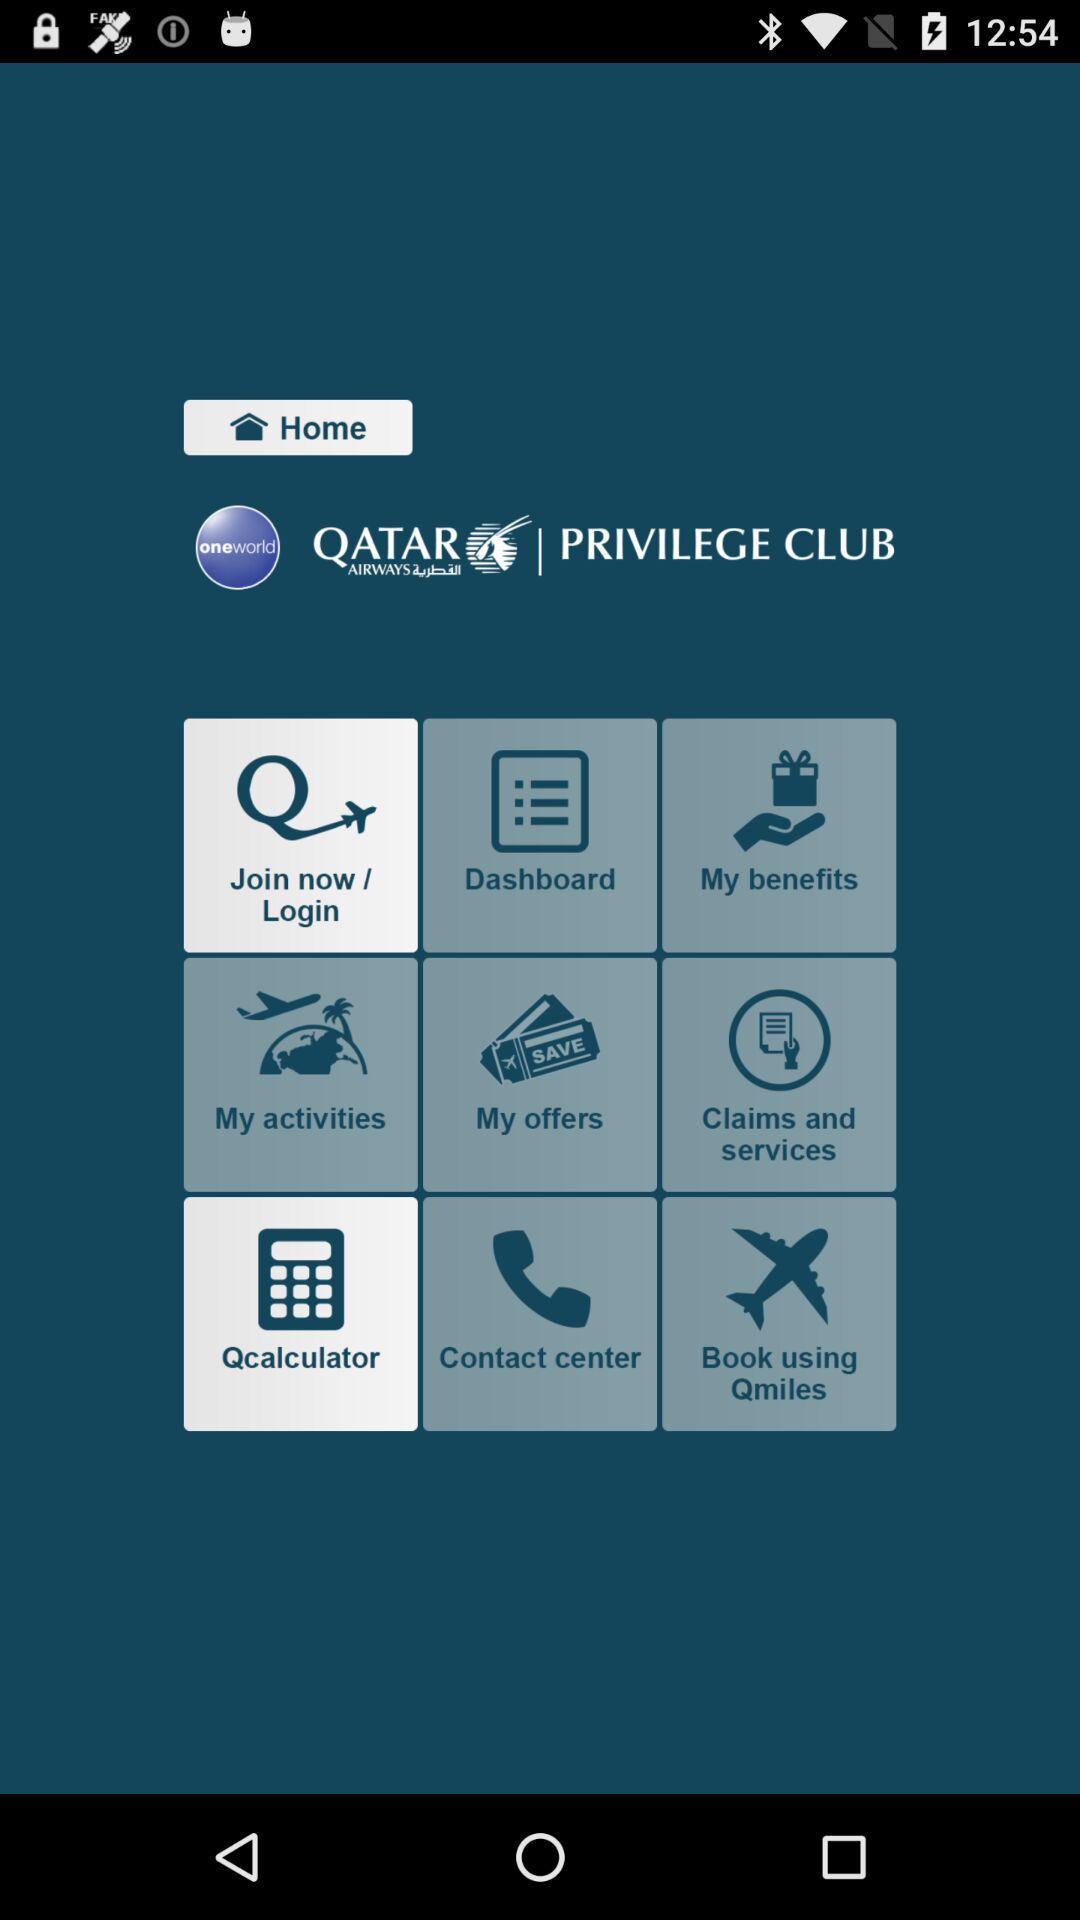What is the name of application?
When the provided information is insufficient, respond with <no answer>. <no answer> 